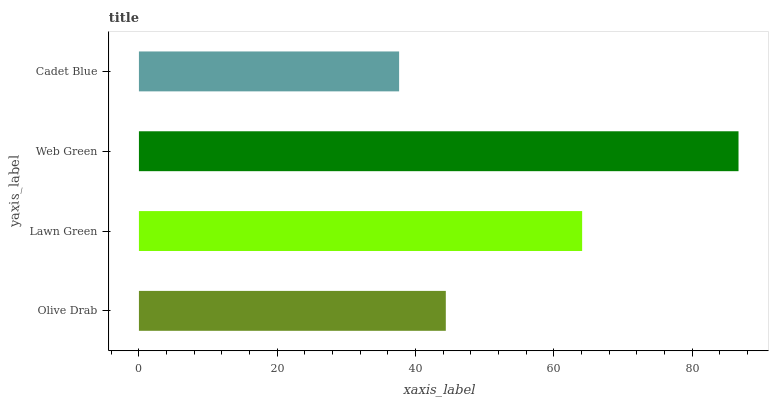Is Cadet Blue the minimum?
Answer yes or no. Yes. Is Web Green the maximum?
Answer yes or no. Yes. Is Lawn Green the minimum?
Answer yes or no. No. Is Lawn Green the maximum?
Answer yes or no. No. Is Lawn Green greater than Olive Drab?
Answer yes or no. Yes. Is Olive Drab less than Lawn Green?
Answer yes or no. Yes. Is Olive Drab greater than Lawn Green?
Answer yes or no. No. Is Lawn Green less than Olive Drab?
Answer yes or no. No. Is Lawn Green the high median?
Answer yes or no. Yes. Is Olive Drab the low median?
Answer yes or no. Yes. Is Cadet Blue the high median?
Answer yes or no. No. Is Cadet Blue the low median?
Answer yes or no. No. 